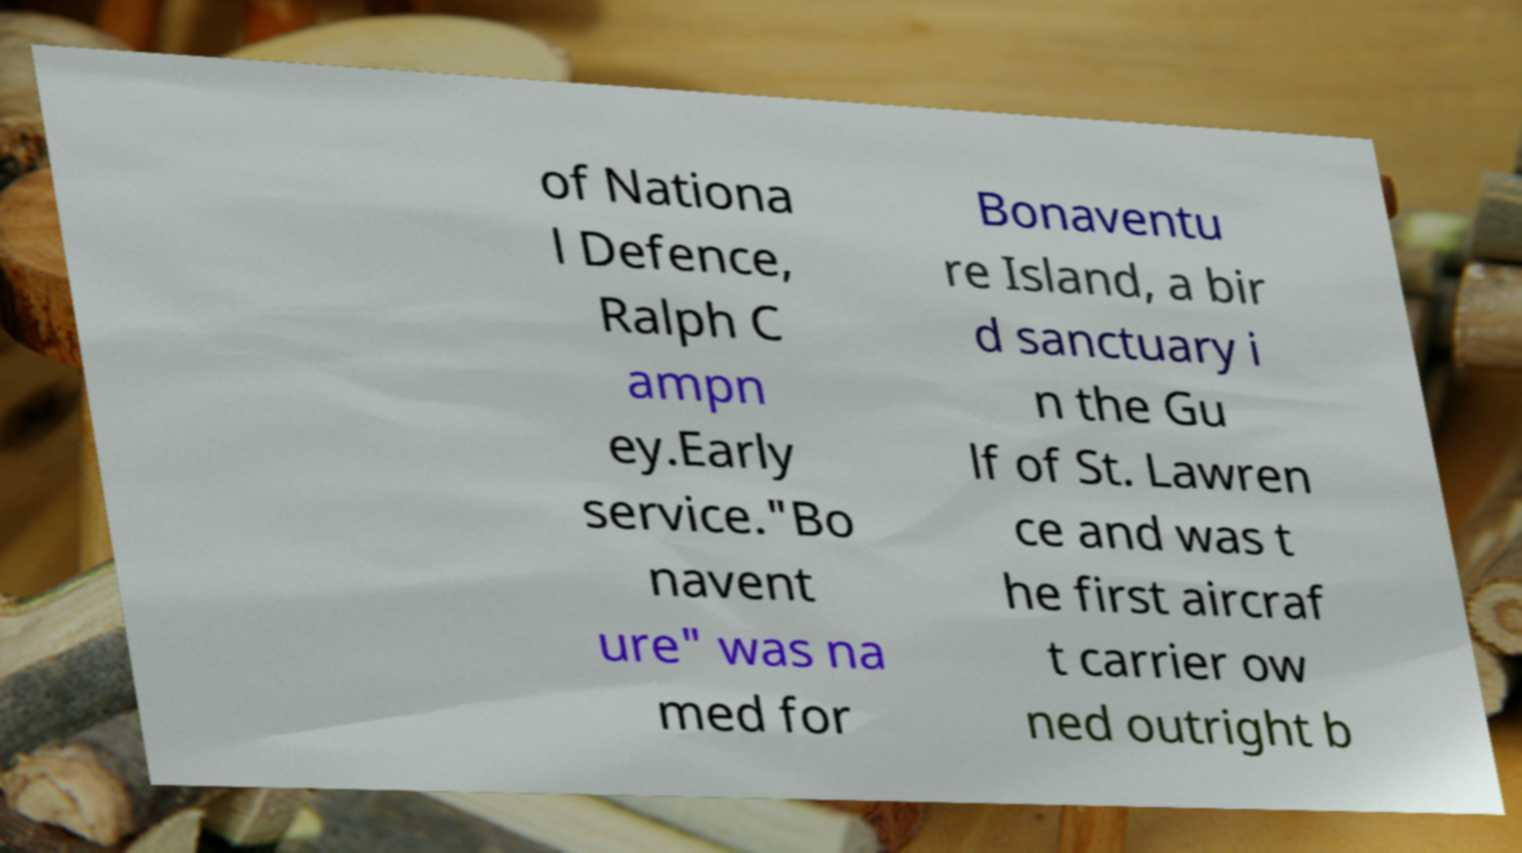Please identify and transcribe the text found in this image. of Nationa l Defence, Ralph C ampn ey.Early service."Bo navent ure" was na med for Bonaventu re Island, a bir d sanctuary i n the Gu lf of St. Lawren ce and was t he first aircraf t carrier ow ned outright b 